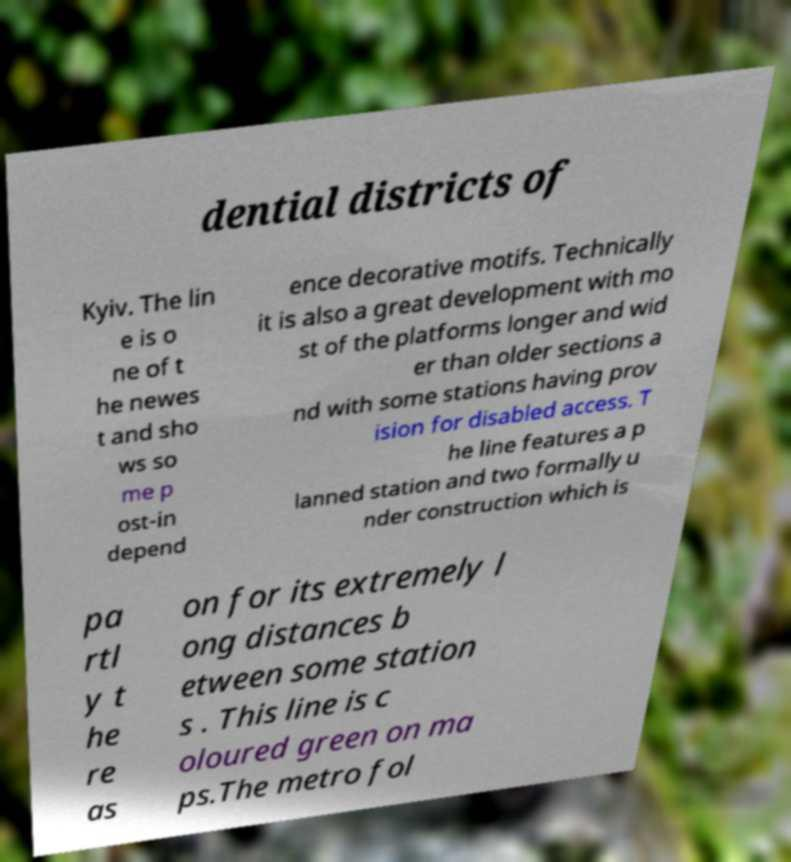I need the written content from this picture converted into text. Can you do that? dential districts of Kyiv. The lin e is o ne of t he newes t and sho ws so me p ost-in depend ence decorative motifs. Technically it is also a great development with mo st of the platforms longer and wid er than older sections a nd with some stations having prov ision for disabled access. T he line features a p lanned station and two formally u nder construction which is pa rtl y t he re as on for its extremely l ong distances b etween some station s . This line is c oloured green on ma ps.The metro fol 